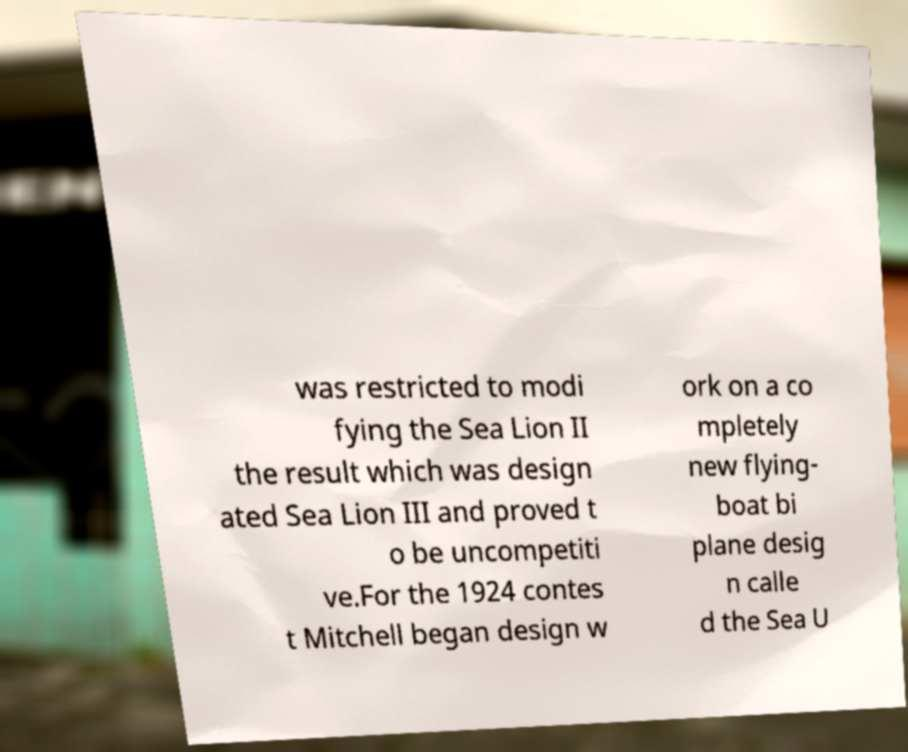Please read and relay the text visible in this image. What does it say? was restricted to modi fying the Sea Lion II the result which was design ated Sea Lion III and proved t o be uncompetiti ve.For the 1924 contes t Mitchell began design w ork on a co mpletely new flying- boat bi plane desig n calle d the Sea U 